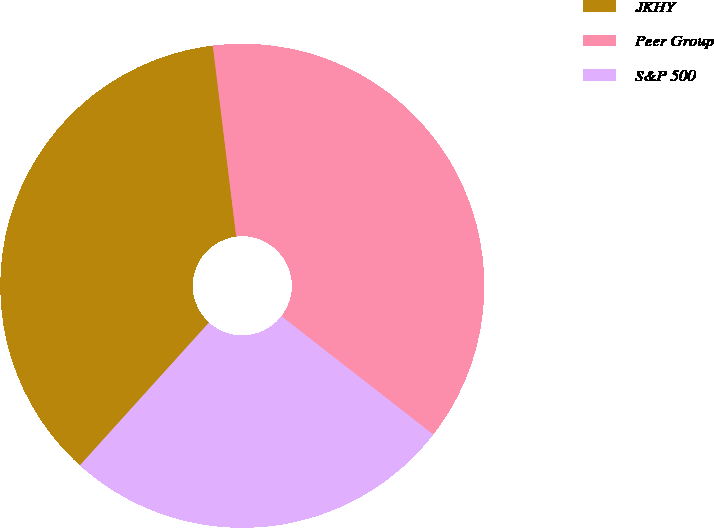Convert chart to OTSL. <chart><loc_0><loc_0><loc_500><loc_500><pie_chart><fcel>JKHY<fcel>Peer Group<fcel>S&P 500<nl><fcel>36.36%<fcel>37.47%<fcel>26.16%<nl></chart> 